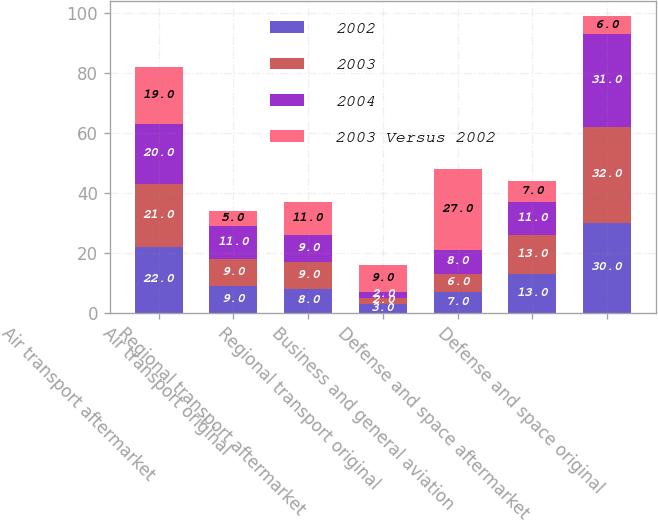Convert chart. <chart><loc_0><loc_0><loc_500><loc_500><stacked_bar_chart><ecel><fcel>Air transport aftermarket<fcel>Air transport original<fcel>Regional transport aftermarket<fcel>Regional transport original<fcel>Business and general aviation<fcel>Defense and space aftermarket<fcel>Defense and space original<nl><fcel>2002<fcel>22<fcel>9<fcel>8<fcel>3<fcel>7<fcel>13<fcel>30<nl><fcel>2003<fcel>21<fcel>9<fcel>9<fcel>2<fcel>6<fcel>13<fcel>32<nl><fcel>2004<fcel>20<fcel>11<fcel>9<fcel>2<fcel>8<fcel>11<fcel>31<nl><fcel>2003 Versus 2002<fcel>19<fcel>5<fcel>11<fcel>9<fcel>27<fcel>7<fcel>6<nl></chart> 